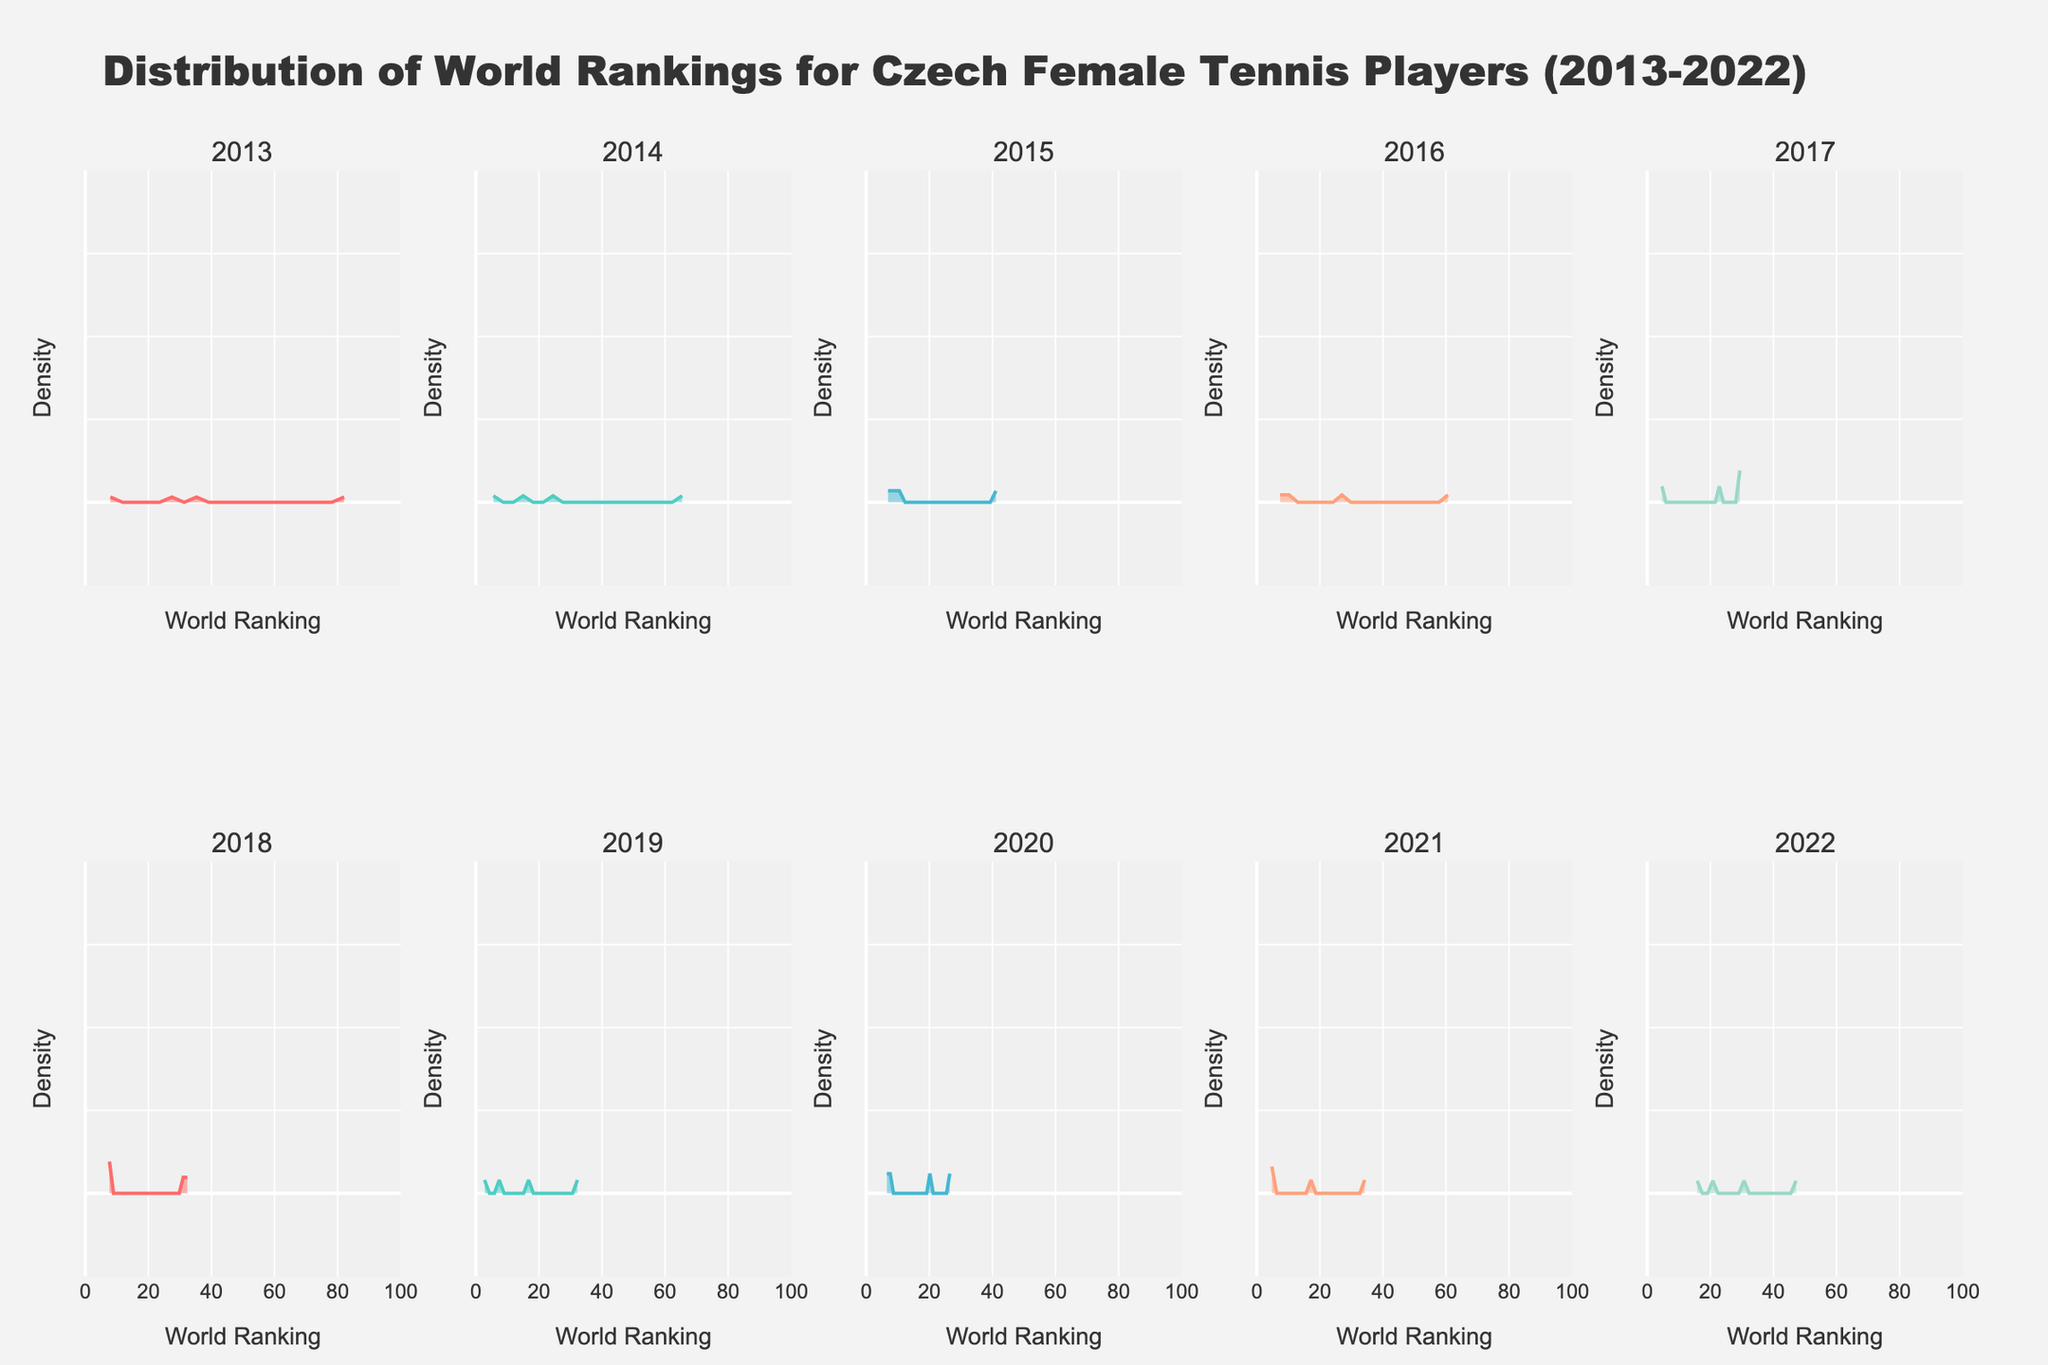What is the title of the figure? The title is the text displayed at the top of the figure. It provides a high-level summary of what the figure represents.
Answer: Distribution of World Rankings for Czech Female Tennis Players (2013-2022) How many years are displayed in the subplots? The individual titles of the subplots represent different years from 2013 to 2022. You count each year title to determine the number of years.
Answer: 10 Which year has the densest peak indicating a lower ranking value? To find this, identify the subplot with the highest density peak that is positioned towards the lower end of the ranking scale on the x-axis.
Answer: 2019 Which player has the highest ranking in 2019, and what is their rank? The rankings per year are represented by the density plots. The 2019 subplot should have a peak towards the top end of the rankings. Based on the given data, the highest ranking in 2019 is for the player with the smallest ranking number.
Answer: Karolina Pliskova, 2 Which years have peak density values located at or below the ranking of 10? Peaks at or below a ranking value of 10 indicate top 10 rankings. Check the subplots for peaks positioned in this range. By examining the positions of peaks from each subplot, identify the years where a peak lies below the ranking value of 10.
Answer: 2013, 2014, 2015, 2017, 2019, 2020, 2021 How does the density distribution for 2013 compare to that of 2017? Compare the shapes, spread, and peak positions of the density plots for the years 2013 and 2017. Notice if they are similar or if one has a higher, wider, or more concentrated distribution than the other.
Answer: 2013 has a wider distribution with peaks around mid-ranking, whereas 2017 has a denser peak indicating concentrated low rankings Is there a year where none of the players were ranked in the top 10? By looking at each subplot, observe if there is any year with a peak only above the top 10 range (i.e., peak density starts from a ranking greater than 10).
Answer: 2016, 2018, 2022 In which year was the highest density peak throughout the entire range of rankings? Identify the subplot that has the highest density peak, regardless of its x-axis position (ranking) compared to other subplots.
Answer: 2015 